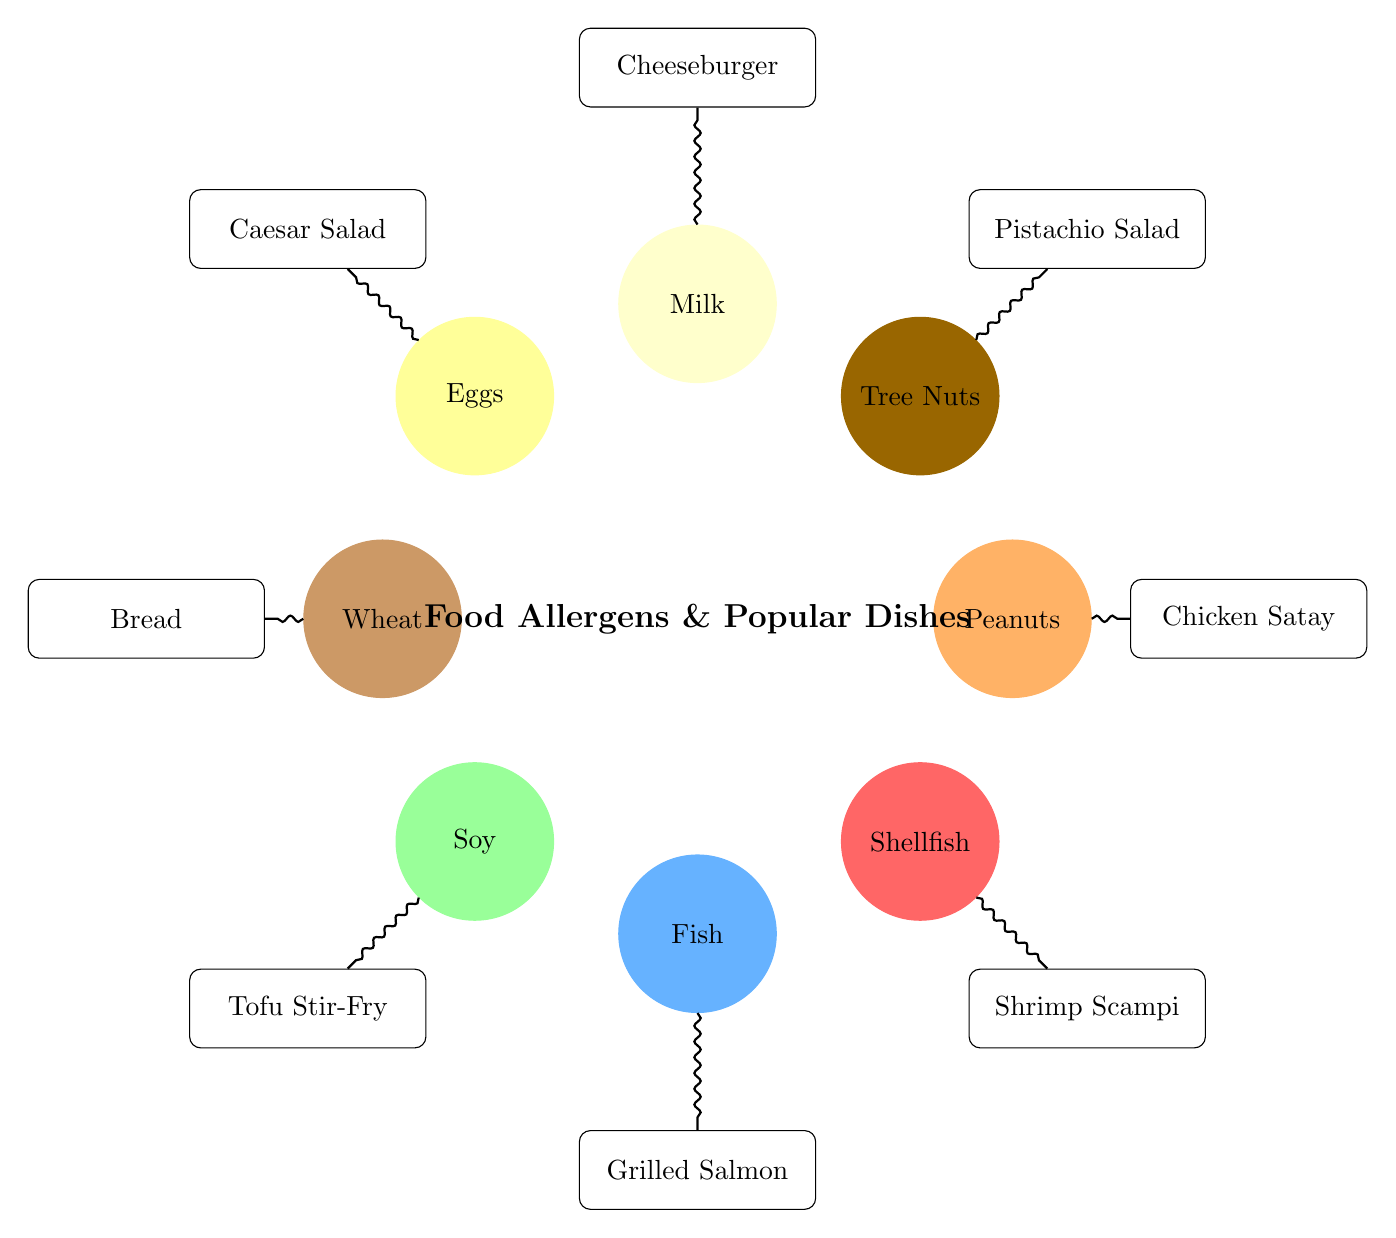What dish is associated with Peanuts? The diagram shows a connection between the "Peanuts" allergen and the "Chicken Satay" dish, represented by a link or edge.
Answer: Chicken Satay Which allergen is linked to Cheeseburger? By examining the links in the diagram, "Milk" is the allergen that connects to "Cheeseburger," indicating a relationship between them.
Answer: Milk How many dishes are represented in the diagram? Counting the nodes that represent dishes in the diagram, there are 8 dish nodes: Chicken Satay, Pistachio Salad, Cheeseburger, Caesar Salad, Bread, Tofu Stir-Fry, Grilled Salmon, and Shrimp Scampi.
Answer: 8 What is the relationship between Wheat and a dish? The diagram highlights that "Wheat" is connected specifically to the "Bread" dish, showing a direct relationship.
Answer: Bread Which allergen is associated with Tofu Stir-Fry? The diagram indicates that "Soy" is linked to "Tofu Stir-Fry," illustrating the allergen's association with this dish.
Answer: Soy Which dish has no allergen listed? Looking closely at the diagram, every dish has at least one allergen linked, and therefore there is no dish without an allergen listed.
Answer: None What is the total number of allergens depicted in the diagram? The diagram includes 8 allergen nodes: Peanuts, Tree Nuts, Milk, Eggs, Wheat, Soy, Fish, and Shellfish.
Answer: 8 How many links connect allergens to dishes in the diagram? By counting the connections shown, there are 8 links connecting various allergens to their respective dishes.
Answer: 8 What dish is related to Shellfish? The diagram shows a direct connection from "Shellfish" to "Shrimp Scampi," indicating their relationship.
Answer: Shrimp Scampi 